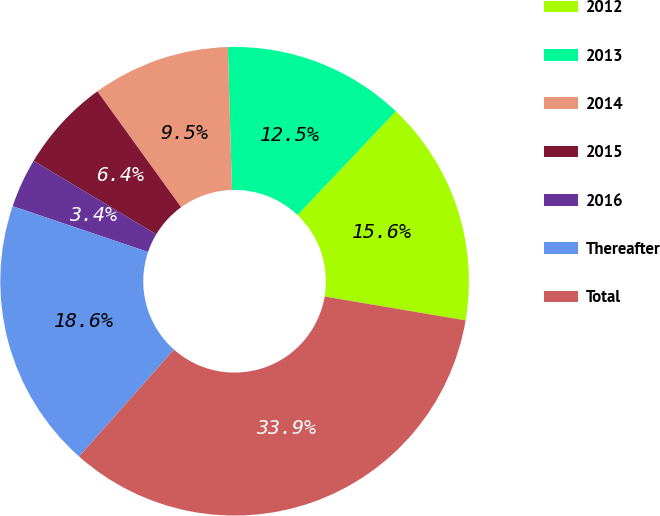Convert chart to OTSL. <chart><loc_0><loc_0><loc_500><loc_500><pie_chart><fcel>2012<fcel>2013<fcel>2014<fcel>2015<fcel>2016<fcel>Thereafter<fcel>Total<nl><fcel>15.59%<fcel>12.54%<fcel>9.5%<fcel>6.45%<fcel>3.4%<fcel>18.64%<fcel>33.88%<nl></chart> 